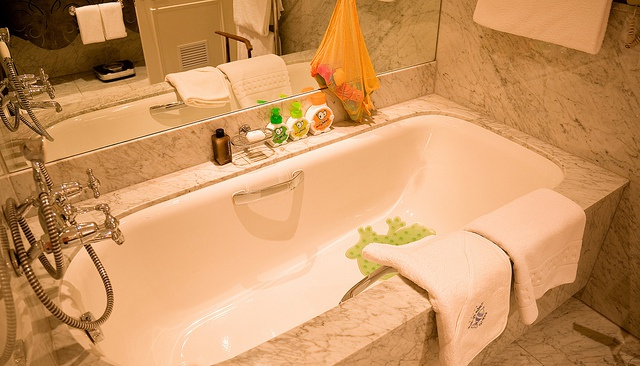Describe the objects in this image and their specific colors. I can see bottle in black, orange, and ivory tones, bottle in black, maroon, and brown tones, bottle in black, orange, ivory, and tan tones, and bottle in black, olive, green, and tan tones in this image. 